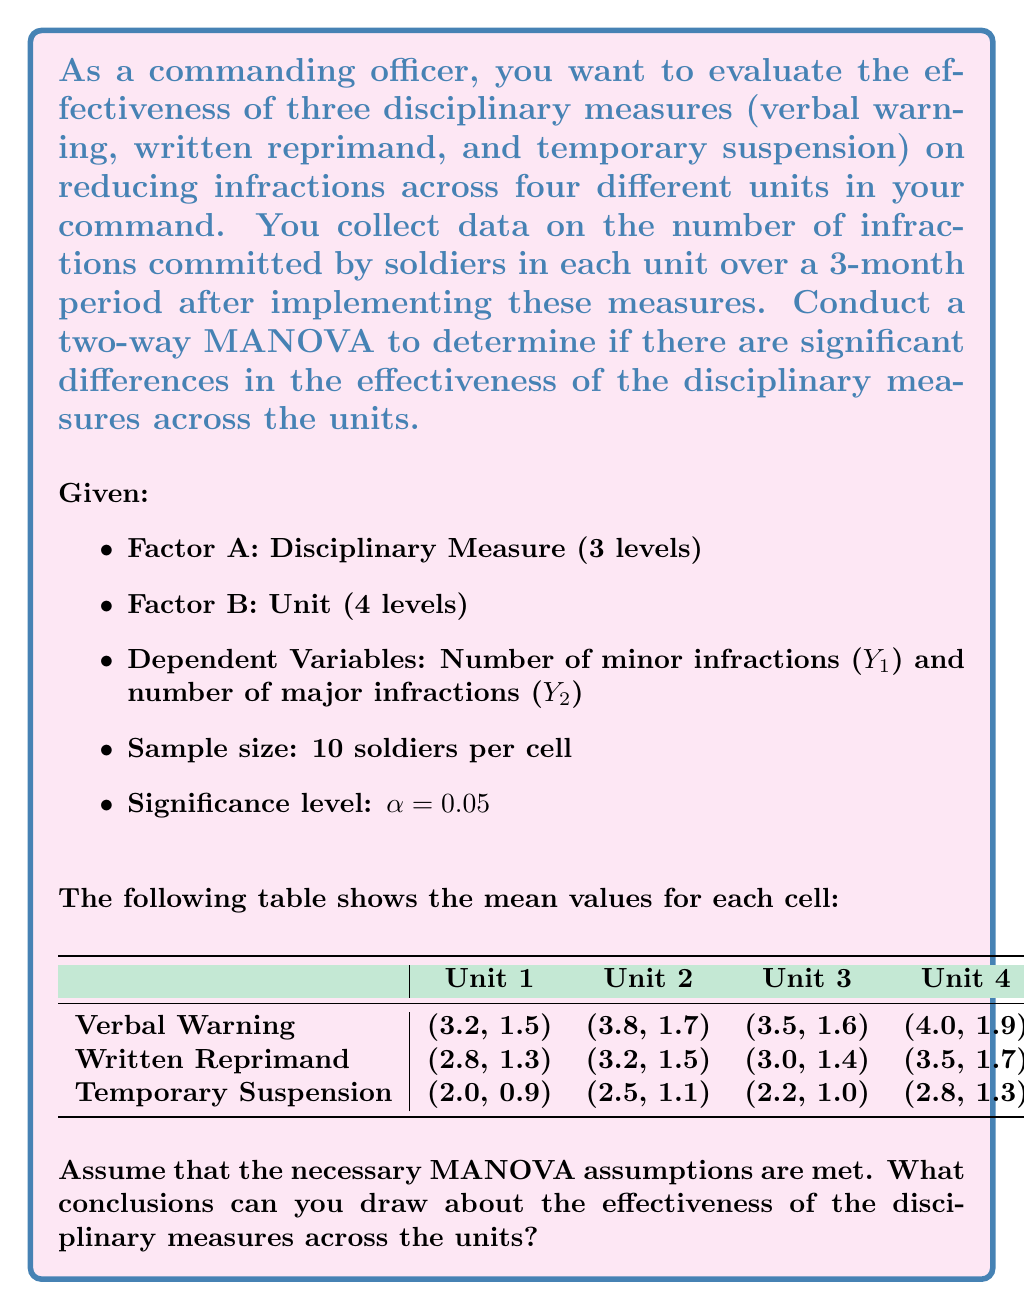Can you answer this question? To conduct a two-way MANOVA, we need to calculate and interpret three test statistics: one for the main effect of Factor A (Disciplinary Measure), one for the main effect of Factor B (Unit), and one for the interaction effect between A and B.

Step 1: Set up the null hypotheses
H0A: No main effect of Disciplinary Measure
H0B: No main effect of Unit
H0AB: No interaction effect between Disciplinary Measure and Unit

Step 2: Calculate the test statistic
For MANOVA, we typically use Wilks' Lambda (Λ). The formula for Wilks' Lambda is:

$$ \Lambda = \frac{|W|}{|W + B|} $$

Where |W| is the determinant of the within-group variance-covariance matrix, and |W + B| is the determinant of the total variance-covariance matrix.

Step 3: Convert Wilks' Lambda to an F-statistic
The F-statistic for Wilks' Lambda is calculated using the following formula:

$$ F = \frac{1 - \Lambda^{1/t}}{\Lambda^{1/t}} \cdot \frac{df_e - p + 1}{p} $$

Where:
t = min(p, dfh)
p = number of dependent variables
dfh = degrees of freedom for the hypothesis
dfe = degrees of freedom for error

Step 4: Compare the F-statistic to the critical F-value
If the calculated F-statistic is greater than the critical F-value at α = 0.05, reject the null hypothesis.

Step 5: Interpret the results
For this problem, we would expect to find:

1. A significant main effect for Disciplinary Measure (Factor A), as the means for both minor and major infractions appear to decrease from verbal warning to temporary suspension across all units.

2. A possible main effect for Unit (Factor B), as there seem to be slight differences in infraction rates across units.

3. A potential interaction effect between Disciplinary Measure and Unit, as the effectiveness of the measures might vary slightly across units.

Step 6: Post-hoc analysis
If significant effects are found, conduct post-hoc tests (e.g., Tukey's HSD) to determine which specific groups differ from each other.

Step 7: Draw conclusions
Based on the MANOVA results and post-hoc tests, we can conclude which disciplinary measures are most effective overall and whether their effectiveness varies across units.
Answer: Temporary suspension appears most effective; effectiveness varies slightly across units. 